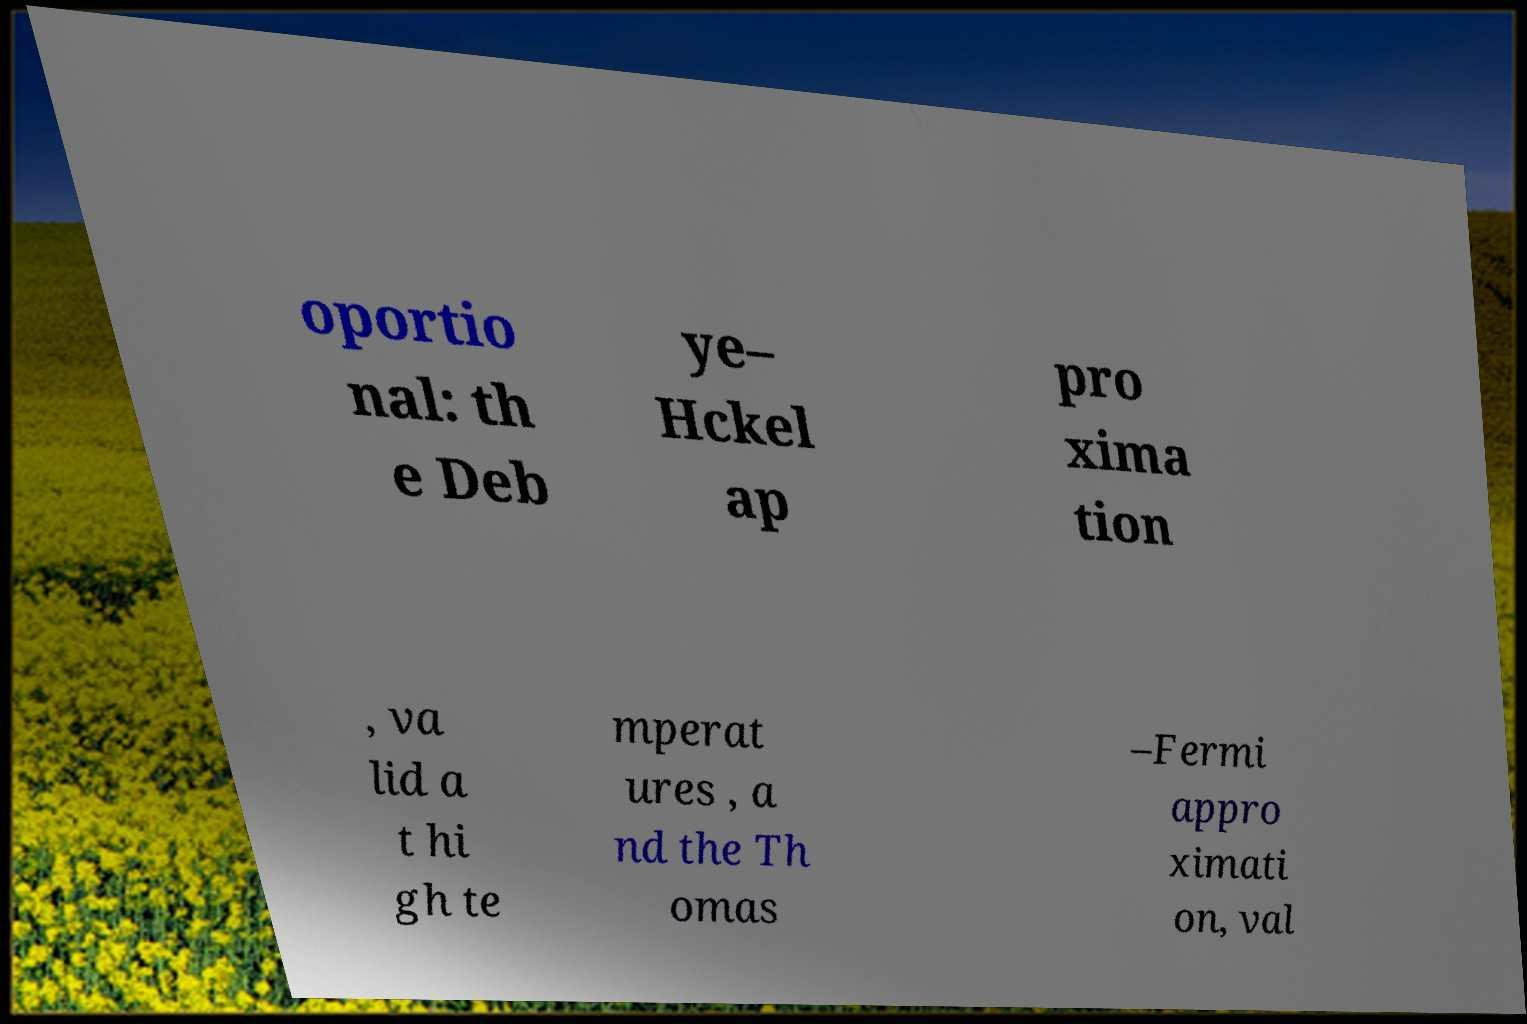Can you read and provide the text displayed in the image?This photo seems to have some interesting text. Can you extract and type it out for me? oportio nal: th e Deb ye– Hckel ap pro xima tion , va lid a t hi gh te mperat ures , a nd the Th omas –Fermi appro ximati on, val 